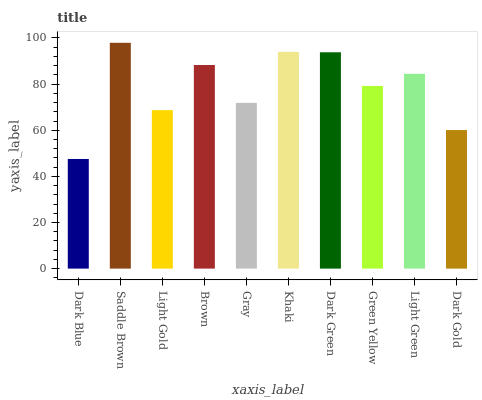Is Dark Blue the minimum?
Answer yes or no. Yes. Is Saddle Brown the maximum?
Answer yes or no. Yes. Is Light Gold the minimum?
Answer yes or no. No. Is Light Gold the maximum?
Answer yes or no. No. Is Saddle Brown greater than Light Gold?
Answer yes or no. Yes. Is Light Gold less than Saddle Brown?
Answer yes or no. Yes. Is Light Gold greater than Saddle Brown?
Answer yes or no. No. Is Saddle Brown less than Light Gold?
Answer yes or no. No. Is Light Green the high median?
Answer yes or no. Yes. Is Green Yellow the low median?
Answer yes or no. Yes. Is Gray the high median?
Answer yes or no. No. Is Dark Blue the low median?
Answer yes or no. No. 